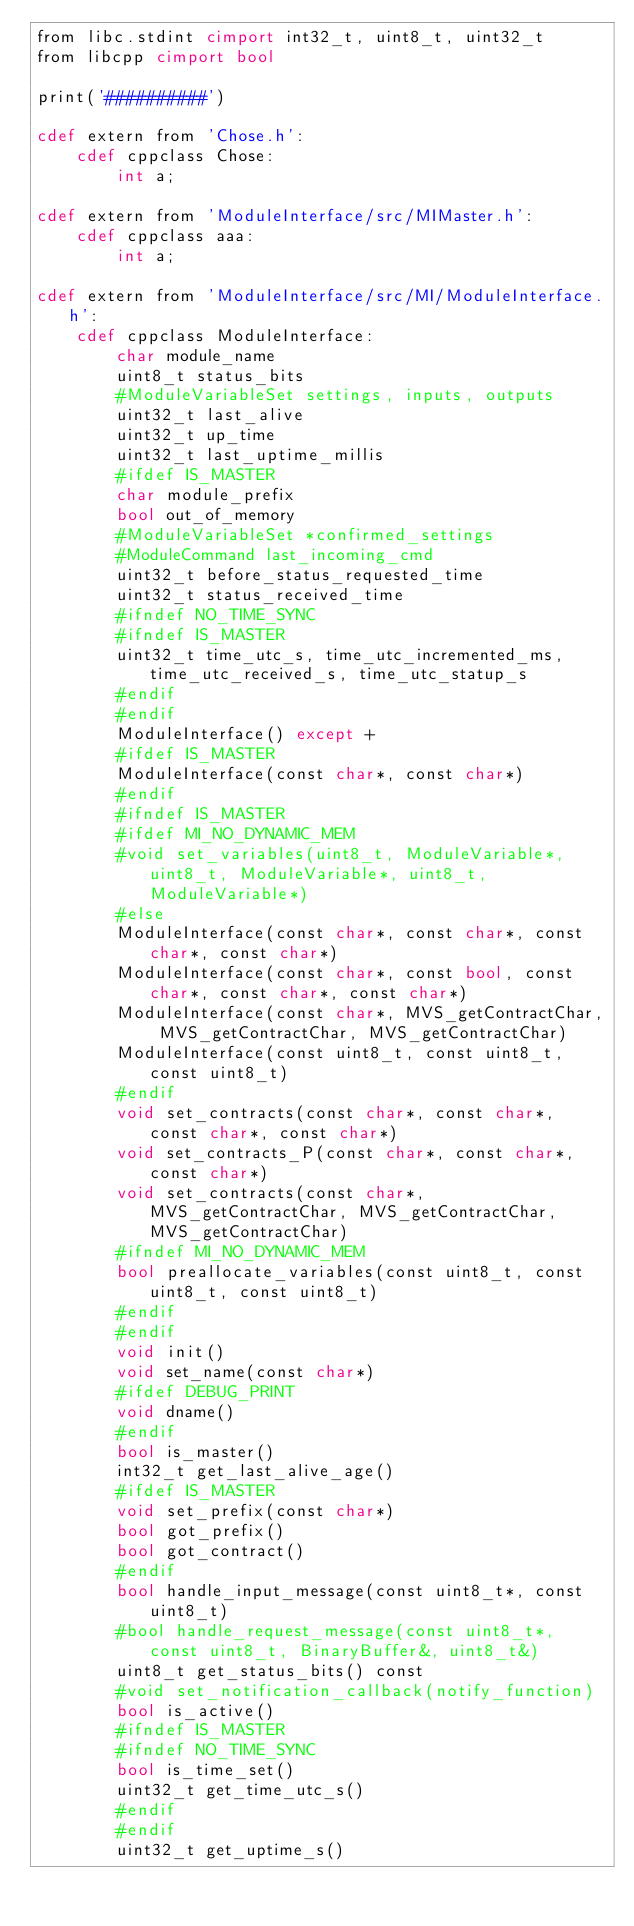<code> <loc_0><loc_0><loc_500><loc_500><_Cython_>from libc.stdint cimport int32_t, uint8_t, uint32_t
from libcpp cimport bool

print('##########')

cdef extern from 'Chose.h':
    cdef cppclass Chose:
        int a;

cdef extern from 'ModuleInterface/src/MIMaster.h':
    cdef cppclass aaa:
        int a;

cdef extern from 'ModuleInterface/src/MI/ModuleInterface.h':
    cdef cppclass ModuleInterface:
        char module_name
        uint8_t status_bits
        #ModuleVariableSet settings, inputs, outputs
        uint32_t last_alive
        uint32_t up_time
        uint32_t last_uptime_millis
        #ifdef IS_MASTER
        char module_prefix
        bool out_of_memory
        #ModuleVariableSet *confirmed_settings
        #ModuleCommand last_incoming_cmd
        uint32_t before_status_requested_time
        uint32_t status_received_time
        #ifndef NO_TIME_SYNC
        #ifndef IS_MASTER
        uint32_t time_utc_s, time_utc_incremented_ms, time_utc_received_s, time_utc_statup_s
        #endif
        #endif
        ModuleInterface() except +
        #ifdef IS_MASTER
        ModuleInterface(const char*, const char*)
        #endif
        #ifndef IS_MASTER
        #ifdef MI_NO_DYNAMIC_MEM
        #void set_variables(uint8_t, ModuleVariable*, uint8_t, ModuleVariable*, uint8_t, ModuleVariable*)
        #else
        ModuleInterface(const char*, const char*, const char*, const char*)
        ModuleInterface(const char*, const bool, const char*, const char*, const char*)
        ModuleInterface(const char*, MVS_getContractChar, MVS_getContractChar, MVS_getContractChar)
        ModuleInterface(const uint8_t, const uint8_t, const uint8_t)
        #endif
        void set_contracts(const char*, const char*, const char*, const char*)
        void set_contracts_P(const char*, const char*, const char*)
        void set_contracts(const char*, MVS_getContractChar, MVS_getContractChar, MVS_getContractChar)
        #ifndef MI_NO_DYNAMIC_MEM
        bool preallocate_variables(const uint8_t, const uint8_t, const uint8_t)
        #endif
        #endif
        void init()
        void set_name(const char*)
        #ifdef DEBUG_PRINT
        void dname()
        #endif
        bool is_master()
        int32_t get_last_alive_age()
        #ifdef IS_MASTER
        void set_prefix(const char*)
        bool got_prefix()
        bool got_contract()
        #endif
        bool handle_input_message(const uint8_t*, const uint8_t)
        #bool handle_request_message(const uint8_t*, const uint8_t, BinaryBuffer&, uint8_t&)
        uint8_t get_status_bits() const
        #void set_notification_callback(notify_function)
        bool is_active()
        #ifndef IS_MASTER
        #ifndef NO_TIME_SYNC
        bool is_time_set()
        uint32_t get_time_utc_s()
        #endif
        #endif
        uint32_t get_uptime_s()
</code> 